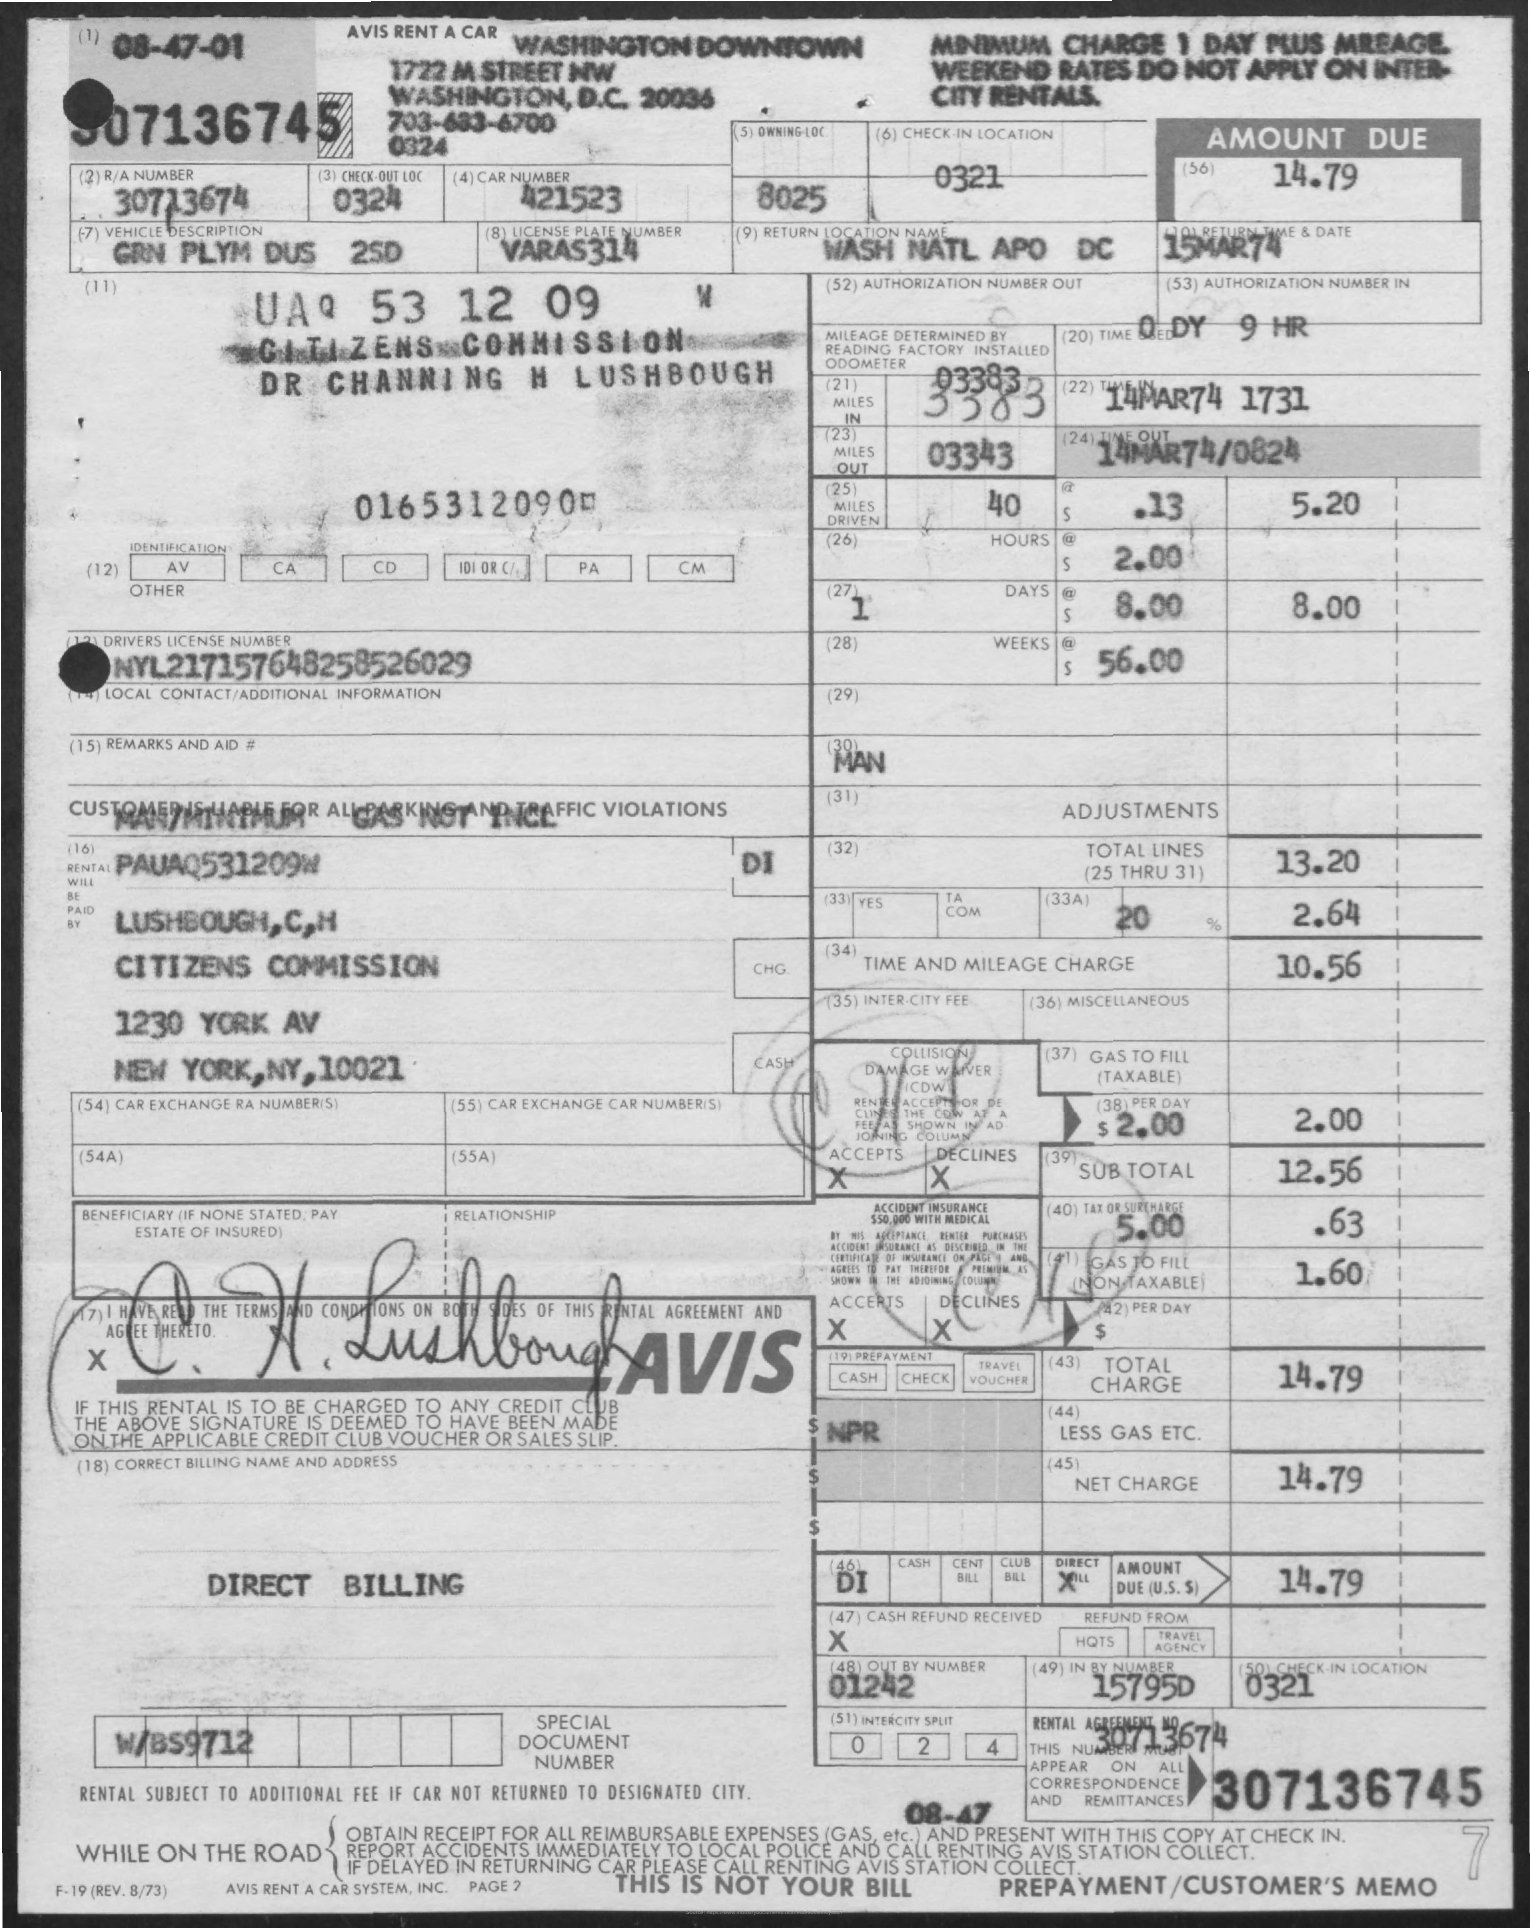Can you provide more details on the items included in the total charge? Certainly! The total charge includes a Time and Mileage charge of $10.56, Collision Waiver of $2.00, and various other charges and adjustments resulting in the final amount of $14.79. 